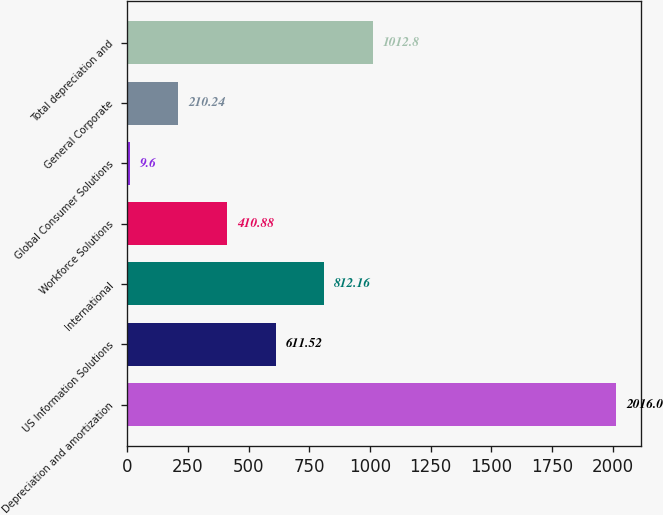Convert chart to OTSL. <chart><loc_0><loc_0><loc_500><loc_500><bar_chart><fcel>Depreciation and amortization<fcel>US Information Solutions<fcel>International<fcel>Workforce Solutions<fcel>Global Consumer Solutions<fcel>General Corporate<fcel>Total depreciation and<nl><fcel>2016<fcel>611.52<fcel>812.16<fcel>410.88<fcel>9.6<fcel>210.24<fcel>1012.8<nl></chart> 